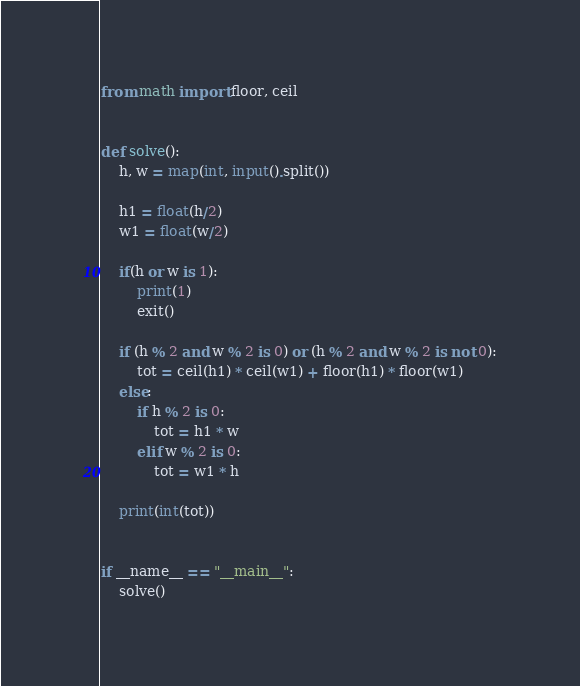<code> <loc_0><loc_0><loc_500><loc_500><_Python_>from math import floor, ceil


def solve():
    h, w = map(int, input().split())

    h1 = float(h/2)
    w1 = float(w/2)

    if(h or w is 1):
        print(1)
        exit()

    if (h % 2 and w % 2 is 0) or (h % 2 and w % 2 is not 0):
        tot = ceil(h1) * ceil(w1) + floor(h1) * floor(w1)
    else:
        if h % 2 is 0:
            tot = h1 * w
        elif w % 2 is 0:
            tot = w1 * h

    print(int(tot))


if __name__ == "__main__":
    solve()
</code> 